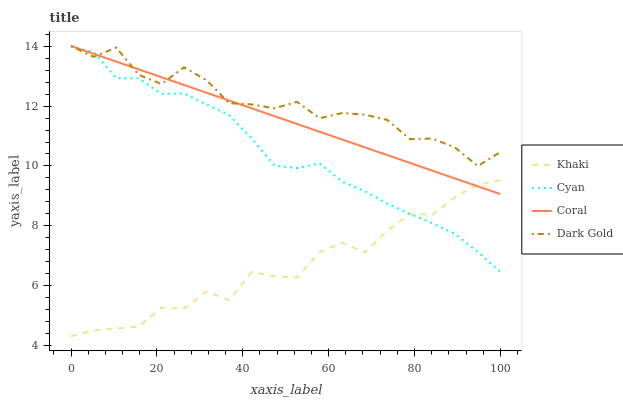Does Khaki have the minimum area under the curve?
Answer yes or no. Yes. Does Dark Gold have the maximum area under the curve?
Answer yes or no. Yes. Does Coral have the minimum area under the curve?
Answer yes or no. No. Does Coral have the maximum area under the curve?
Answer yes or no. No. Is Coral the smoothest?
Answer yes or no. Yes. Is Dark Gold the roughest?
Answer yes or no. Yes. Is Khaki the smoothest?
Answer yes or no. No. Is Khaki the roughest?
Answer yes or no. No. Does Khaki have the lowest value?
Answer yes or no. Yes. Does Coral have the lowest value?
Answer yes or no. No. Does Dark Gold have the highest value?
Answer yes or no. Yes. Does Khaki have the highest value?
Answer yes or no. No. Is Khaki less than Dark Gold?
Answer yes or no. Yes. Is Dark Gold greater than Khaki?
Answer yes or no. Yes. Does Cyan intersect Khaki?
Answer yes or no. Yes. Is Cyan less than Khaki?
Answer yes or no. No. Is Cyan greater than Khaki?
Answer yes or no. No. Does Khaki intersect Dark Gold?
Answer yes or no. No. 